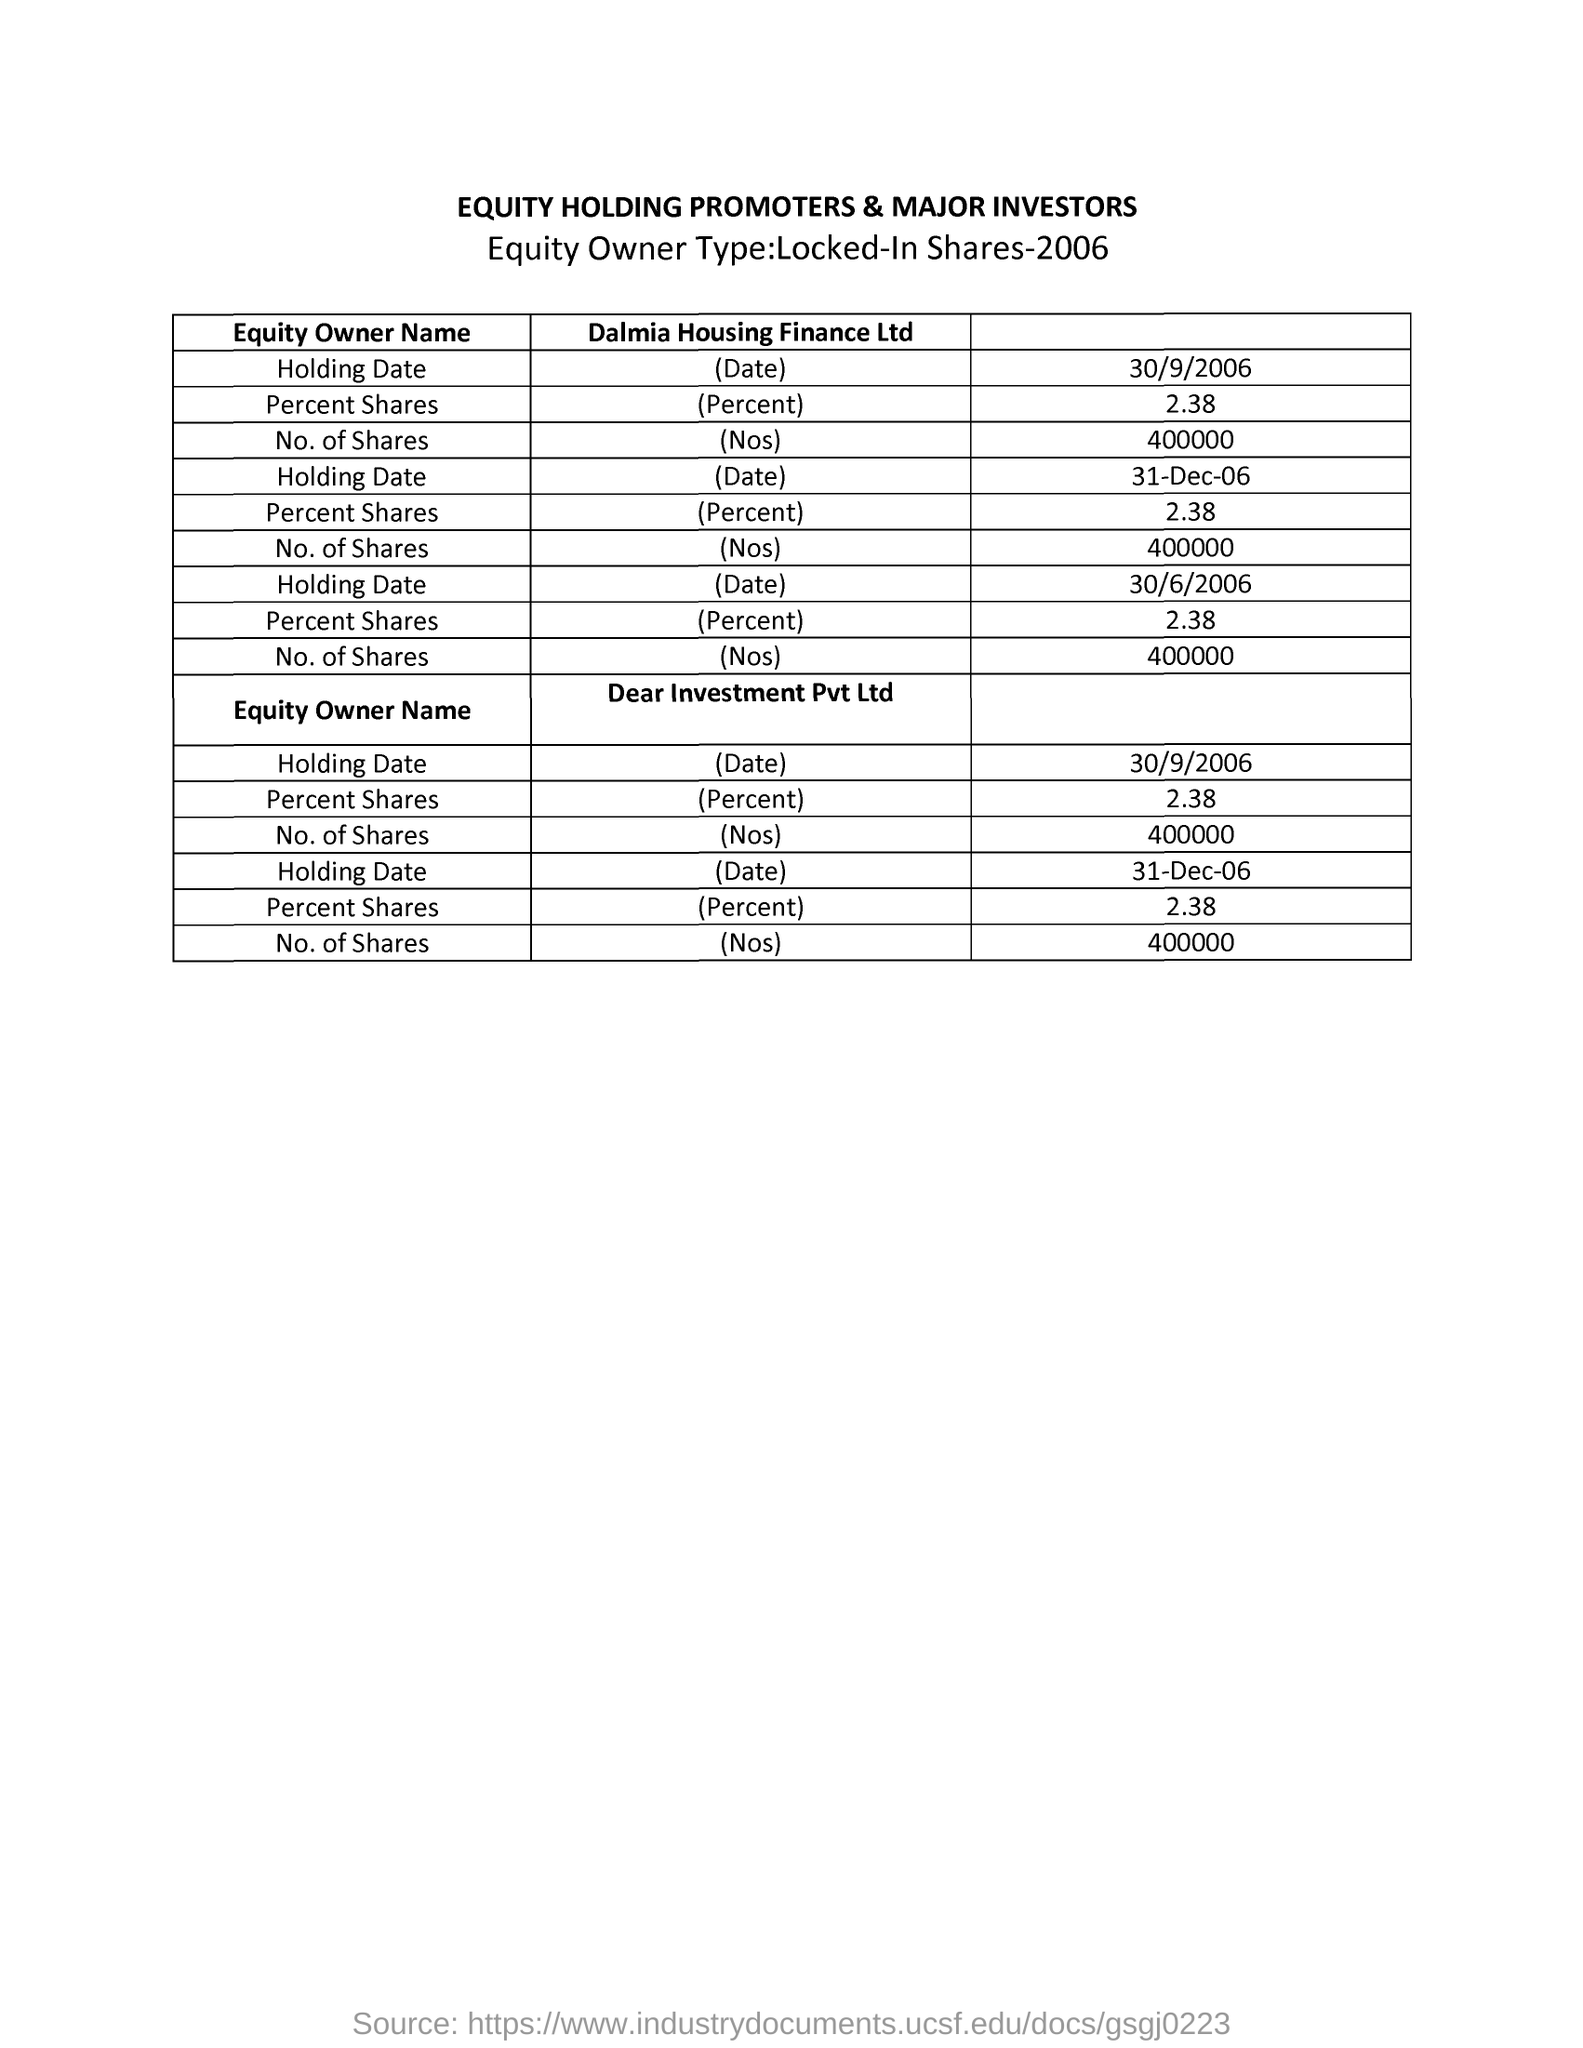Give some essential details in this illustration. On September 30th, 2006, there were 400,000 shares of Dalmia Housing Finance Ltd available. 